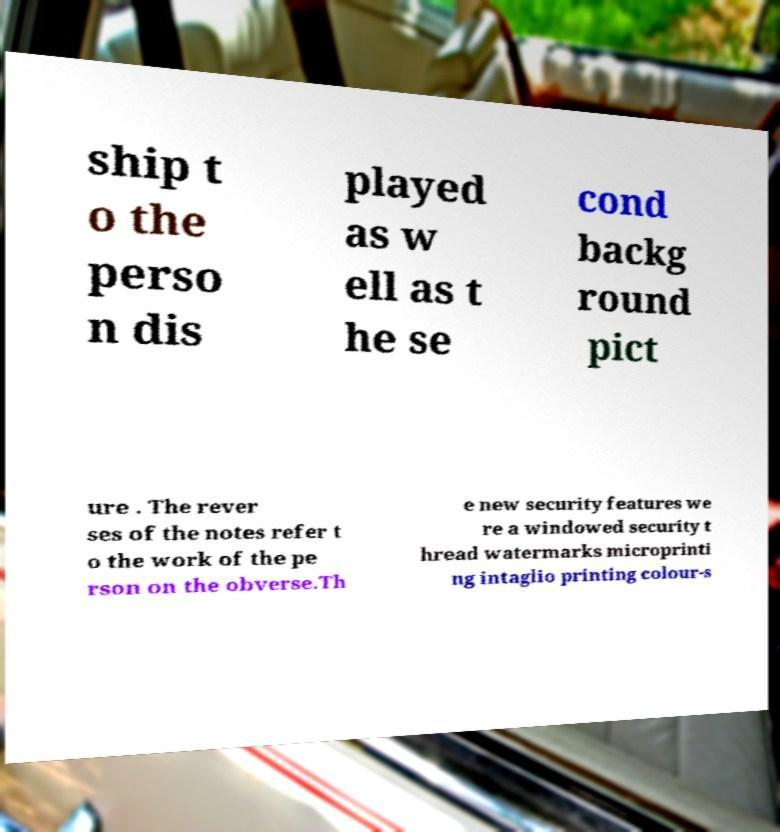What messages or text are displayed in this image? I need them in a readable, typed format. ship t o the perso n dis played as w ell as t he se cond backg round pict ure . The rever ses of the notes refer t o the work of the pe rson on the obverse.Th e new security features we re a windowed security t hread watermarks microprinti ng intaglio printing colour-s 